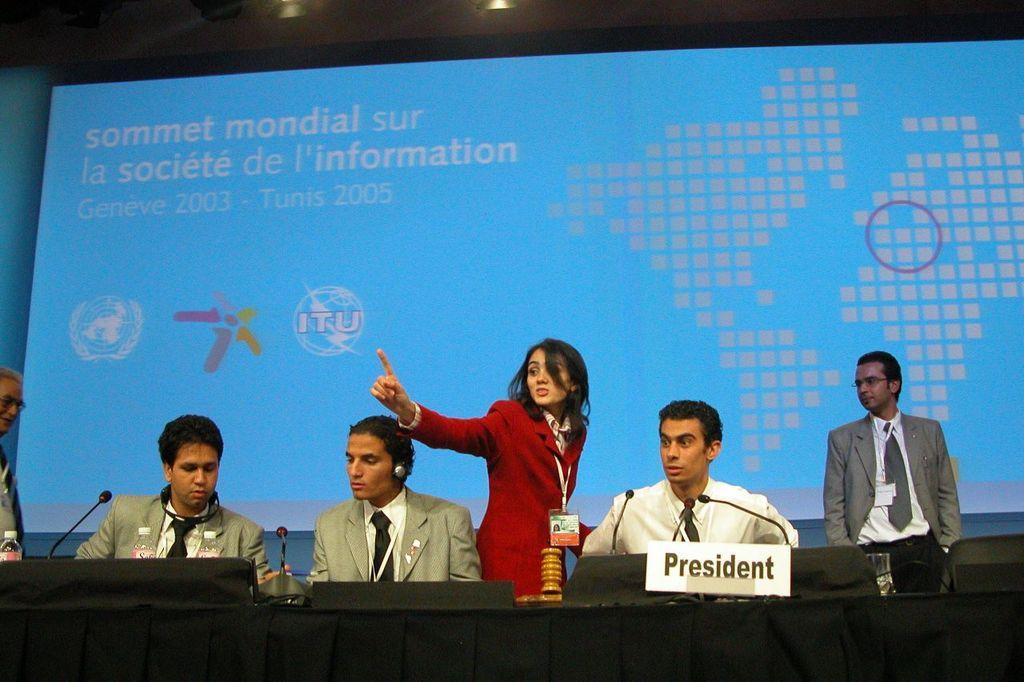Can you describe this image briefly? In this picture, we see three men are sitting on the chairs. In front of them, we see a black table on which microphones and water bottles are placed. We see a white board with "President" written on it is placed on the table. The woman in red blazer is pointing towards something and she is trying to talk something. On the right side, the man in grey blazer is standing. On the left side, the man in grey blazer is also standing. Behind them, we see a projector screen displaying something. This picture might be clicked in the conference hall. 